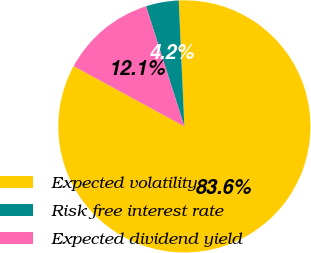Convert chart. <chart><loc_0><loc_0><loc_500><loc_500><pie_chart><fcel>Expected volatility<fcel>Risk free interest rate<fcel>Expected dividend yield<nl><fcel>83.64%<fcel>4.21%<fcel>12.15%<nl></chart> 